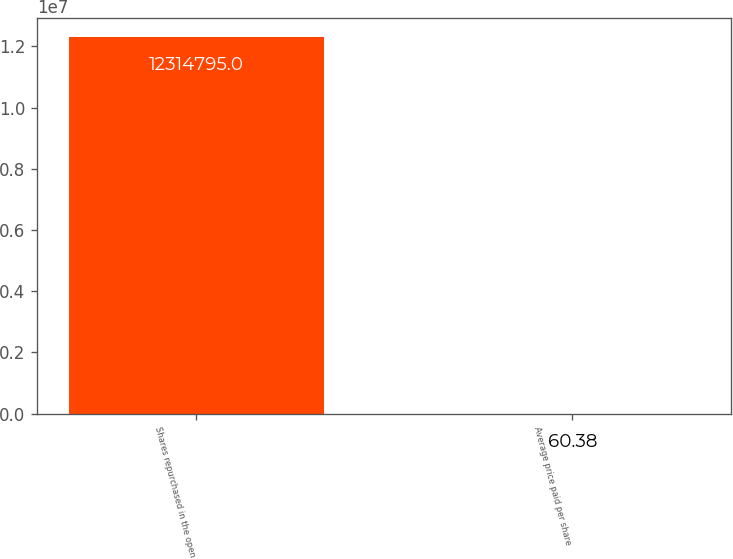Convert chart to OTSL. <chart><loc_0><loc_0><loc_500><loc_500><bar_chart><fcel>Shares repurchased in the open<fcel>Average price paid per share<nl><fcel>1.23148e+07<fcel>60.38<nl></chart> 